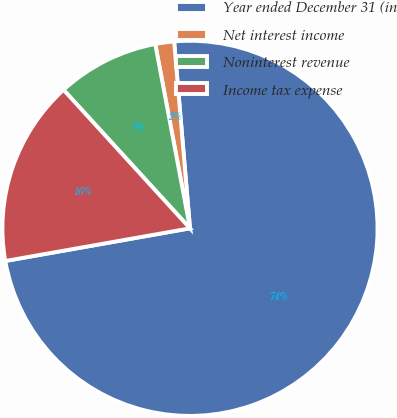Convert chart to OTSL. <chart><loc_0><loc_0><loc_500><loc_500><pie_chart><fcel>Year ended December 31 (in<fcel>Net interest income<fcel>Noninterest revenue<fcel>Income tax expense<nl><fcel>73.57%<fcel>1.62%<fcel>8.81%<fcel>16.01%<nl></chart> 